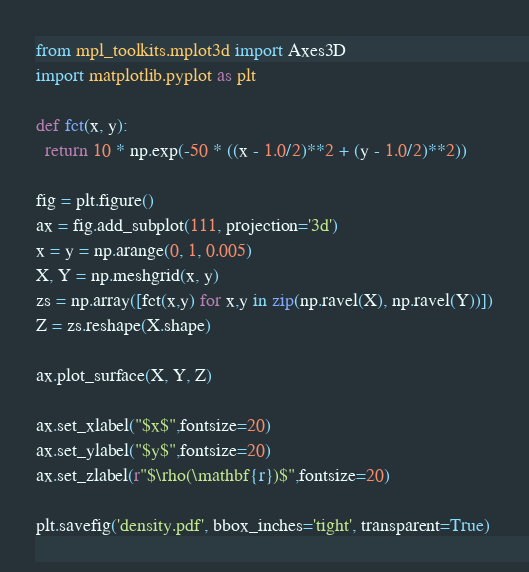Convert code to text. <code><loc_0><loc_0><loc_500><loc_500><_Python_>from mpl_toolkits.mplot3d import Axes3D
import matplotlib.pyplot as plt

def fct(x, y):
  return 10 * np.exp(-50 * ((x - 1.0/2)**2 + (y - 1.0/2)**2))

fig = plt.figure()
ax = fig.add_subplot(111, projection='3d')
x = y = np.arange(0, 1, 0.005)
X, Y = np.meshgrid(x, y)
zs = np.array([fct(x,y) for x,y in zip(np.ravel(X), np.ravel(Y))])
Z = zs.reshape(X.shape)

ax.plot_surface(X, Y, Z)

ax.set_xlabel("$x$",fontsize=20)
ax.set_ylabel("$y$",fontsize=20)
ax.set_zlabel(r"$\rho(\mathbf{r})$",fontsize=20)

plt.savefig('density.pdf', bbox_inches='tight', transparent=True)
</code> 